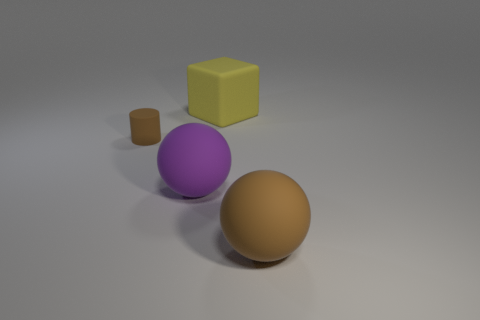There is a rubber sphere behind the large brown object; does it have the same color as the small object?
Your answer should be very brief. No. How many rubber objects are either tiny brown cylinders or tiny green blocks?
Provide a succinct answer. 1. What is the shape of the purple object?
Offer a terse response. Sphere. Are there any other things that have the same material as the cylinder?
Your answer should be very brief. Yes. Do the large purple object and the yellow thing have the same material?
Your answer should be very brief. Yes. Is there a big rubber object in front of the matte object that is behind the rubber thing that is left of the big purple thing?
Make the answer very short. Yes. How many other things are the same shape as the purple rubber thing?
Provide a succinct answer. 1. What shape is the thing that is right of the purple rubber ball and to the left of the large brown object?
Ensure brevity in your answer.  Cube. There is a large rubber object behind the brown thing on the left side of the large matte ball to the left of the matte block; what is its color?
Your response must be concise. Yellow. Are there more large purple rubber objects that are to the left of the cube than small brown matte objects that are behind the small brown object?
Ensure brevity in your answer.  Yes. 